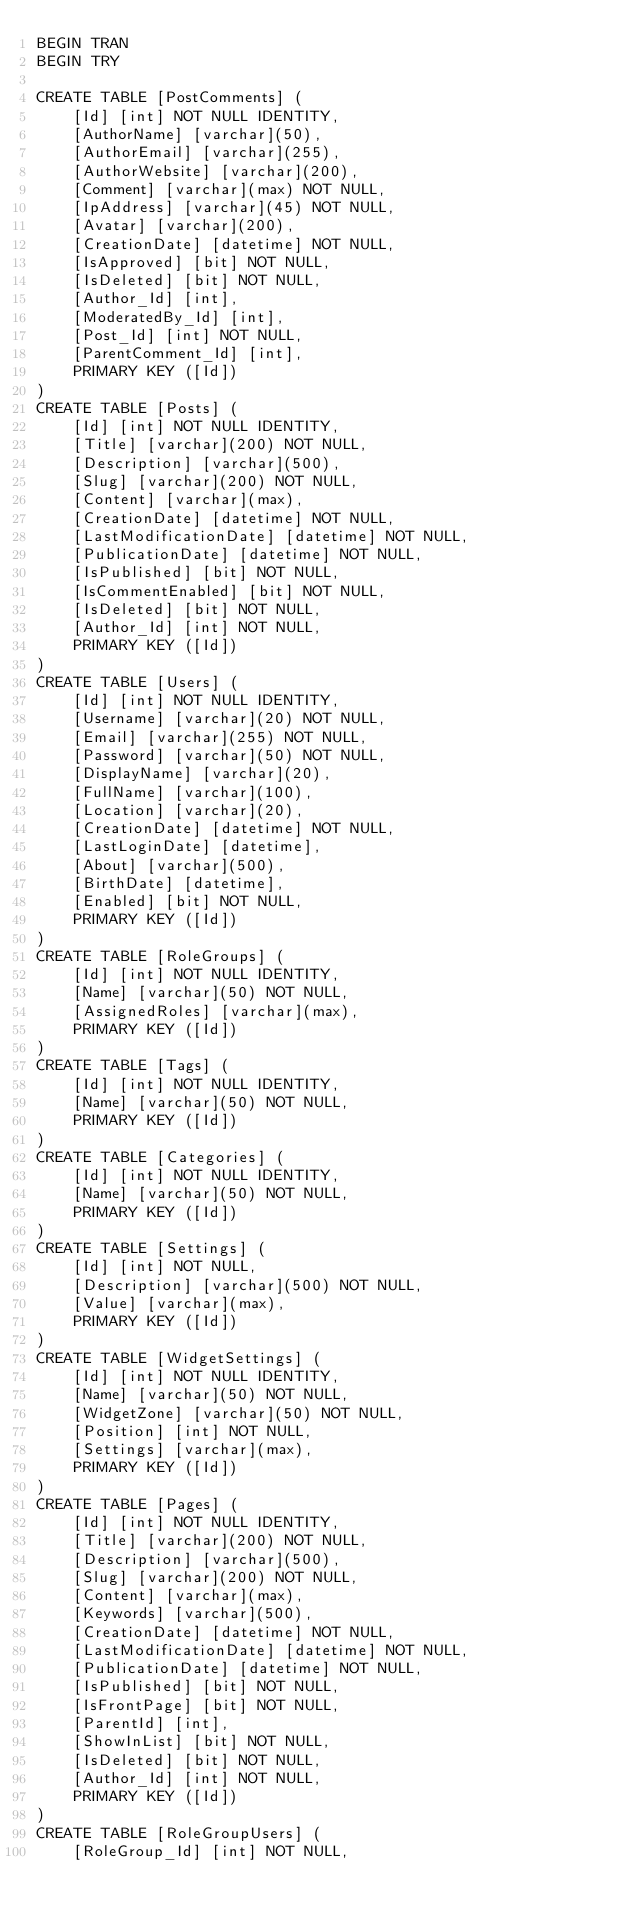Convert code to text. <code><loc_0><loc_0><loc_500><loc_500><_SQL_>BEGIN TRAN
BEGIN TRY

CREATE TABLE [PostComments] (
    [Id] [int] NOT NULL IDENTITY,
    [AuthorName] [varchar](50),
    [AuthorEmail] [varchar](255),
    [AuthorWebsite] [varchar](200),
    [Comment] [varchar](max) NOT NULL,
    [IpAddress] [varchar](45) NOT NULL,
    [Avatar] [varchar](200),
    [CreationDate] [datetime] NOT NULL,
    [IsApproved] [bit] NOT NULL,
    [IsDeleted] [bit] NOT NULL,
    [Author_Id] [int],
    [ModeratedBy_Id] [int],
    [Post_Id] [int] NOT NULL,
    [ParentComment_Id] [int],
    PRIMARY KEY ([Id])
)
CREATE TABLE [Posts] (
    [Id] [int] NOT NULL IDENTITY,
    [Title] [varchar](200) NOT NULL,
    [Description] [varchar](500),
    [Slug] [varchar](200) NOT NULL,
    [Content] [varchar](max),
    [CreationDate] [datetime] NOT NULL,
    [LastModificationDate] [datetime] NOT NULL,
    [PublicationDate] [datetime] NOT NULL,
    [IsPublished] [bit] NOT NULL,
    [IsCommentEnabled] [bit] NOT NULL,
    [IsDeleted] [bit] NOT NULL,
    [Author_Id] [int] NOT NULL,
    PRIMARY KEY ([Id])
)
CREATE TABLE [Users] (
    [Id] [int] NOT NULL IDENTITY,
    [Username] [varchar](20) NOT NULL,
    [Email] [varchar](255) NOT NULL,
    [Password] [varchar](50) NOT NULL,
    [DisplayName] [varchar](20),
    [FullName] [varchar](100),
    [Location] [varchar](20),
    [CreationDate] [datetime] NOT NULL,
    [LastLoginDate] [datetime],
    [About] [varchar](500),
    [BirthDate] [datetime],
    [Enabled] [bit] NOT NULL,
    PRIMARY KEY ([Id])
)
CREATE TABLE [RoleGroups] (
    [Id] [int] NOT NULL IDENTITY,
    [Name] [varchar](50) NOT NULL,
    [AssignedRoles] [varchar](max),
    PRIMARY KEY ([Id])
)
CREATE TABLE [Tags] (
    [Id] [int] NOT NULL IDENTITY,
    [Name] [varchar](50) NOT NULL,
    PRIMARY KEY ([Id])
)
CREATE TABLE [Categories] (
    [Id] [int] NOT NULL IDENTITY,
    [Name] [varchar](50) NOT NULL,
    PRIMARY KEY ([Id])
)
CREATE TABLE [Settings] (
    [Id] [int] NOT NULL,
    [Description] [varchar](500) NOT NULL,
    [Value] [varchar](max),
    PRIMARY KEY ([Id])
)
CREATE TABLE [WidgetSettings] (
    [Id] [int] NOT NULL IDENTITY,
    [Name] [varchar](50) NOT NULL,
    [WidgetZone] [varchar](50) NOT NULL,
    [Position] [int] NOT NULL,
    [Settings] [varchar](max),
    PRIMARY KEY ([Id])
)
CREATE TABLE [Pages] (
    [Id] [int] NOT NULL IDENTITY,
    [Title] [varchar](200) NOT NULL,
    [Description] [varchar](500),
    [Slug] [varchar](200) NOT NULL,
    [Content] [varchar](max),
    [Keywords] [varchar](500),
    [CreationDate] [datetime] NOT NULL,
    [LastModificationDate] [datetime] NOT NULL,
    [PublicationDate] [datetime] NOT NULL,
    [IsPublished] [bit] NOT NULL,
    [IsFrontPage] [bit] NOT NULL,
    [ParentId] [int],
    [ShowInList] [bit] NOT NULL,
    [IsDeleted] [bit] NOT NULL,
    [Author_Id] [int] NOT NULL,
    PRIMARY KEY ([Id])
)
CREATE TABLE [RoleGroupUsers] (
    [RoleGroup_Id] [int] NOT NULL,</code> 